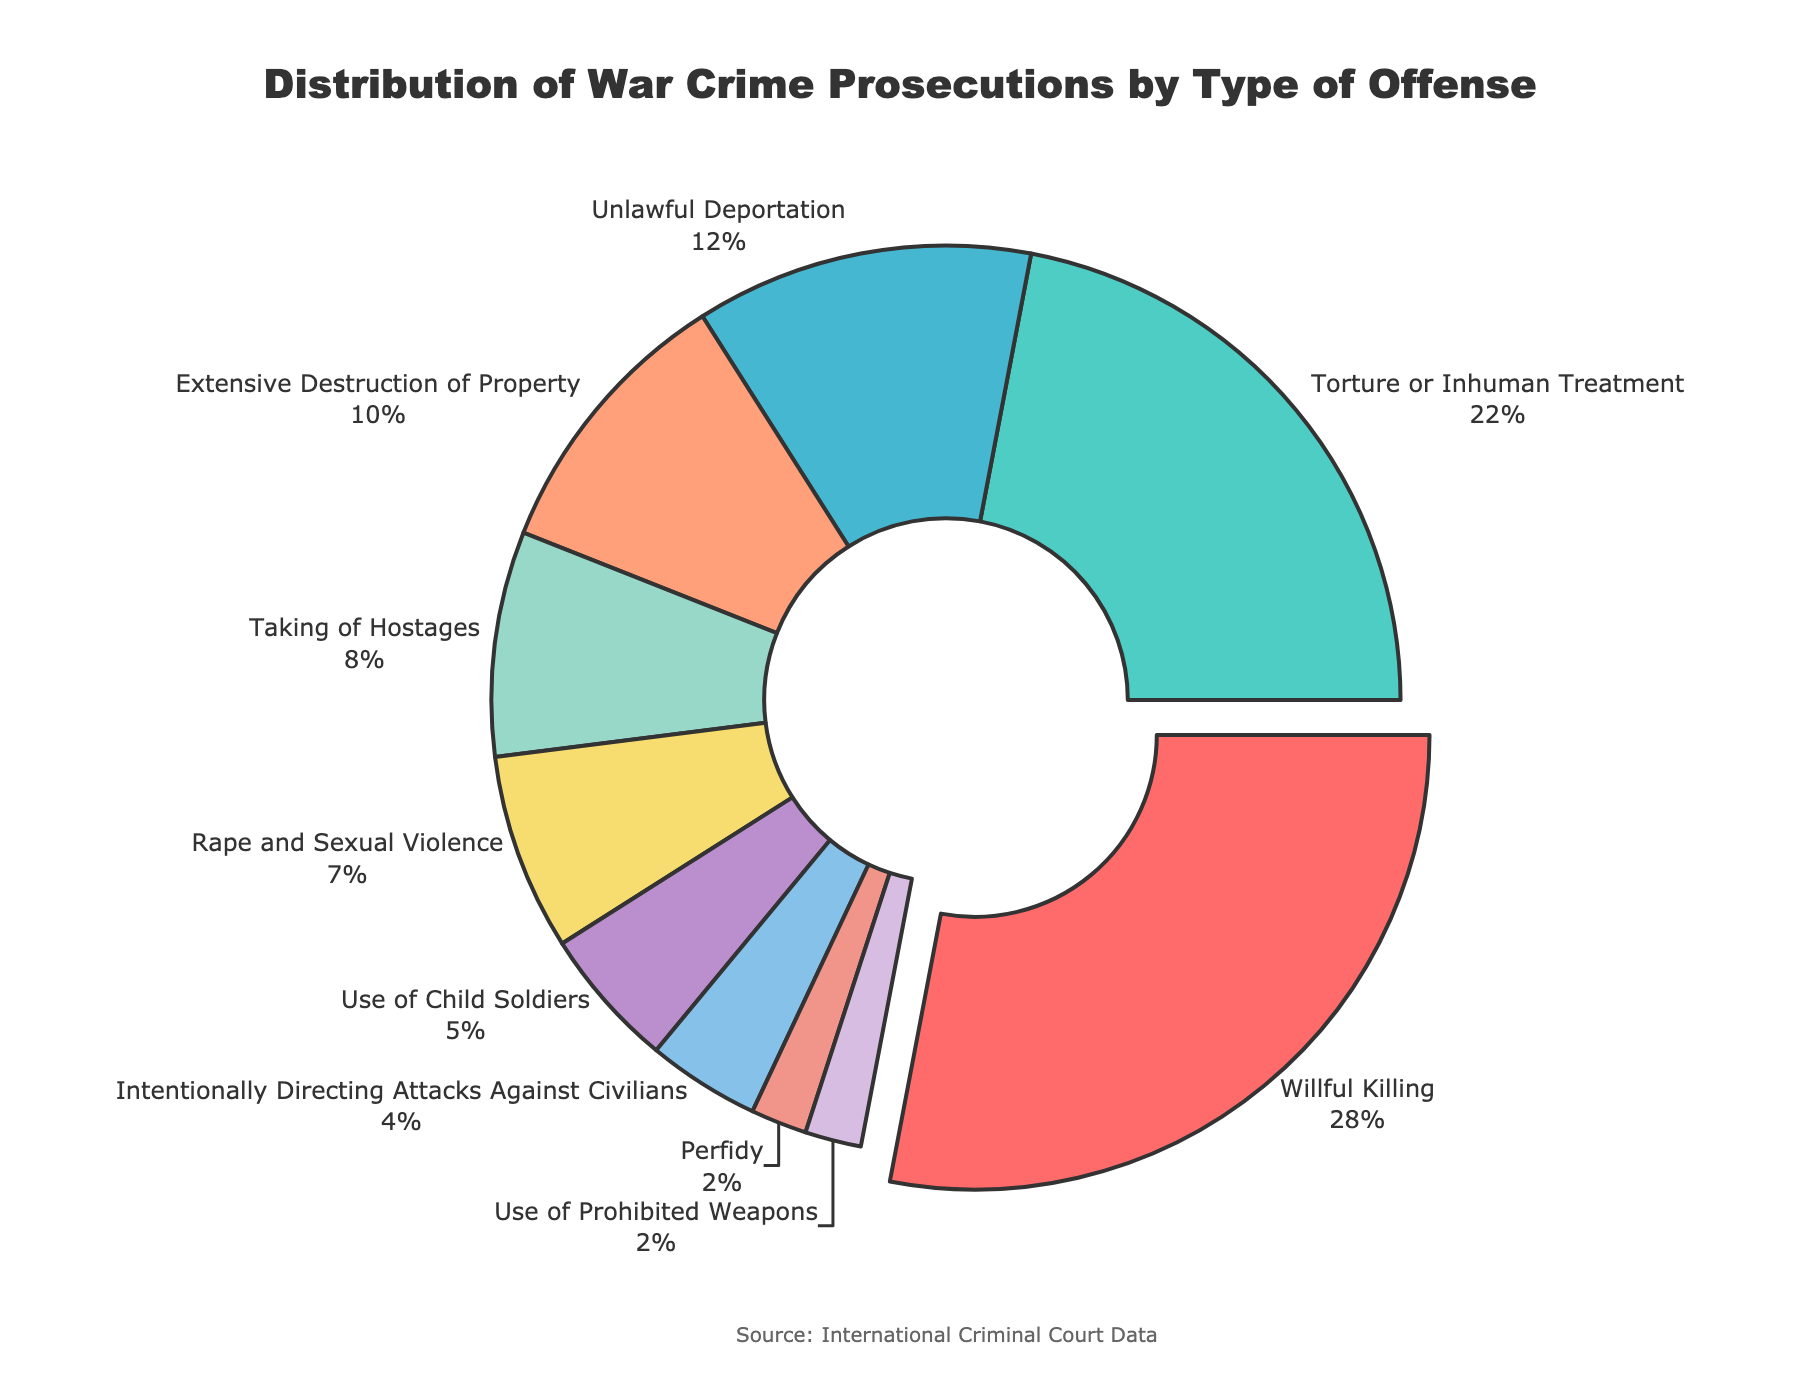What type of war crime has the highest percentage? The pie chart shows segments representing different types of war crimes with their respective percentages. The largest segment indicates the highest percentage.
Answer: Willful Killing Which war crime constitutes the smallest percentage of prosecutions? To find the smallest percentage, identify the smallest segment in the pie chart.
Answer: Perfidy and Use of Prohibited Weapons How much greater is the percentage of Willful Killing compared to Unlawful Deportation? Subtract the percentage of Unlawful Deportation from that of Willful Killing. 28% - 12% = 16%.
Answer: 16% What is the total percentage of rape and sexual violence combined with the use of child soldiers? Add the percentages of Rape and Sexual Violence and Use of Child Soldiers. 7% + 5% = 12%.
Answer: 12% Which type of war crime is represented by the green segment? Identify the green segment in the pie chart and check the label associated with it.
Answer: Torture or Inhuman Treatment Is the percentage of Taking of Hostages greater or less than that of Extensive Destruction of Property? Compare the percentages of Taking of Hostages (8%) and Extensive Destruction of Property (10%) from the pie chart.
Answer: Less What is the combined percentage of the two least prosecuted war crimes? Identify the two smallest segments: Perfidy and Use of Prohibited Weapons. Add their percentages. 2% + 2% = 4%.
Answer: 4% Which segment is positioned next to the largest segment in a clockwise direction? Look at the segment immediately following the largest segment (Willful Killing) in a clockwise direction on the pie chart.
Answer: Torture or Inhuman Treatment What percentage of war crime prosecutions do the top three most prosecuted war crimes make up? Add the percentages of the top three segments: Willful Killing (28%), Torture or Inhuman Treatment (22%), and Unlawful Deportation (12%). 28% + 22% + 12% = 62%.
Answer: 62% Comparing Intentionally Directing Attacks Against Civilians and Use of Child Soldiers, which has the higher percentage, and by how much? Check the percentages of each. Use of Child Soldiers is 5% whereas Intentionally Directing Attacks Against Civilians is 4%. Subtract 4% from 5%.
Answer: Use of Child Soldiers by 1% 